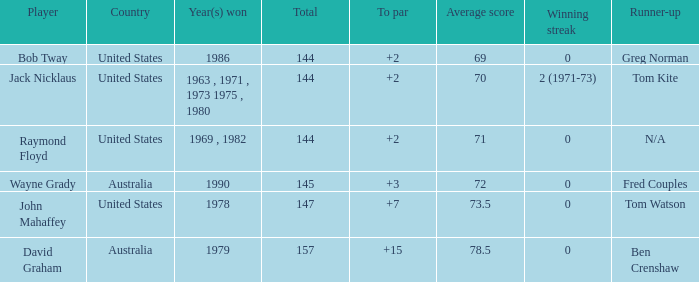What was the winner's score relative to par in 1978? 7.0. Could you parse the entire table? {'header': ['Player', 'Country', 'Year(s) won', 'Total', 'To par', 'Average score', 'Winning streak', 'Runner-up'], 'rows': [['Bob Tway', 'United States', '1986', '144', '+2', '69', '0', 'Greg Norman'], ['Jack Nicklaus', 'United States', '1963 , 1971 , 1973 1975 , 1980', '144', '+2', '70', '2 (1971-73)', 'Tom Kite'], ['Raymond Floyd', 'United States', '1969 , 1982', '144', '+2', '71', '0', 'N/A'], ['Wayne Grady', 'Australia', '1990', '145', '+3', '72', '0', 'Fred Couples'], ['John Mahaffey', 'United States', '1978', '147', '+7', '73.5', '0', 'Tom Watson'], ['David Graham', 'Australia', '1979', '157', '+15', '78.5', '0', 'Ben Crenshaw']]} 